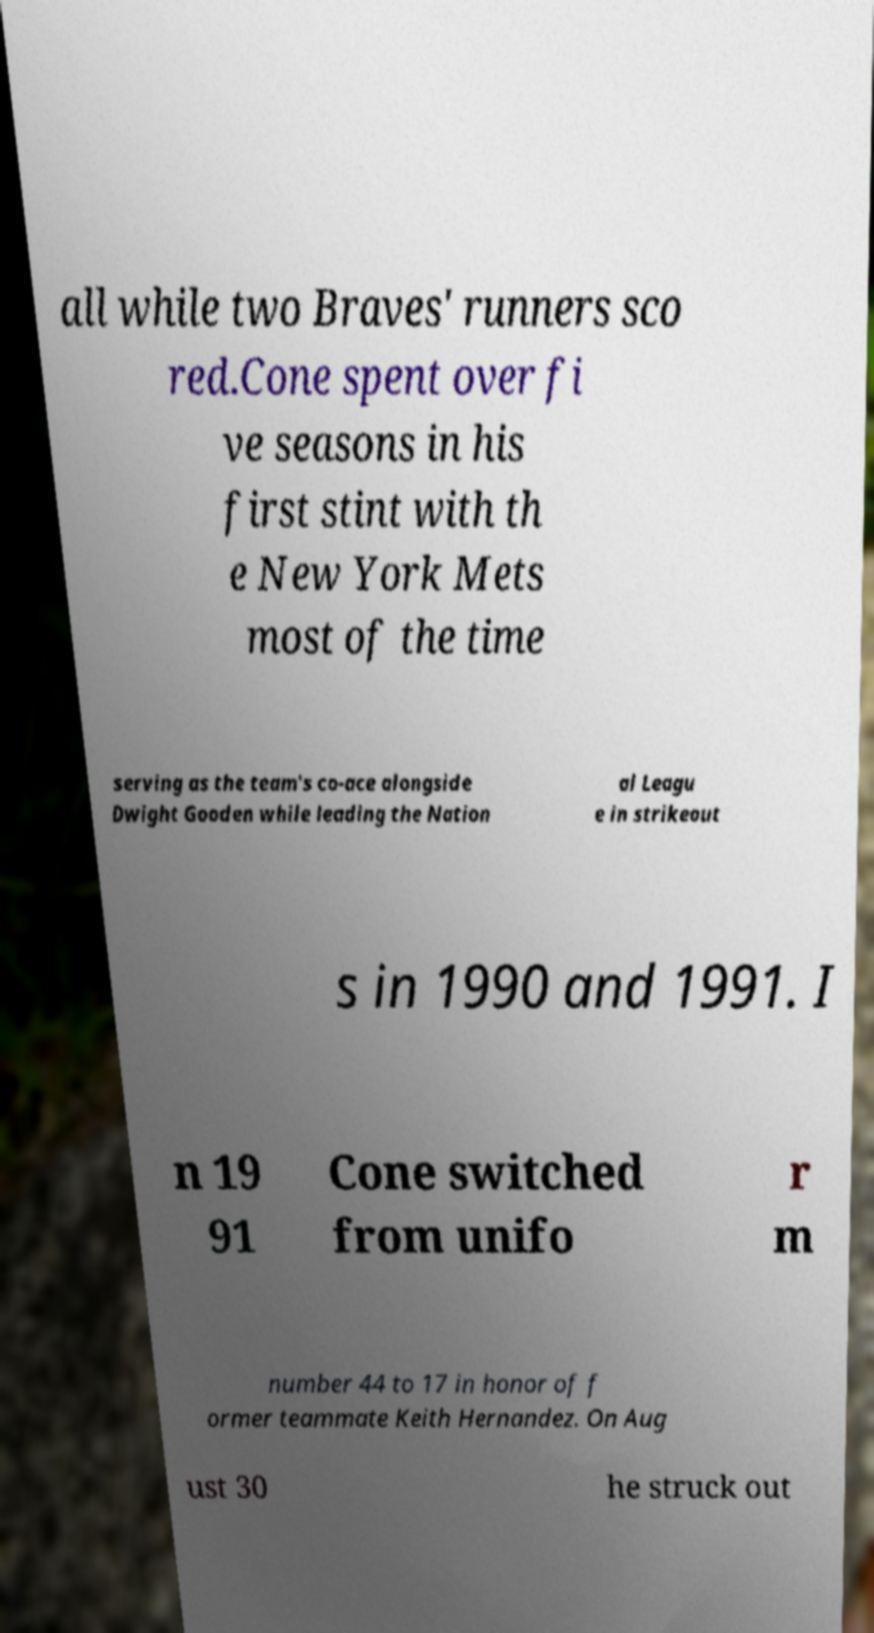Could you extract and type out the text from this image? all while two Braves' runners sco red.Cone spent over fi ve seasons in his first stint with th e New York Mets most of the time serving as the team's co-ace alongside Dwight Gooden while leading the Nation al Leagu e in strikeout s in 1990 and 1991. I n 19 91 Cone switched from unifo r m number 44 to 17 in honor of f ormer teammate Keith Hernandez. On Aug ust 30 he struck out 